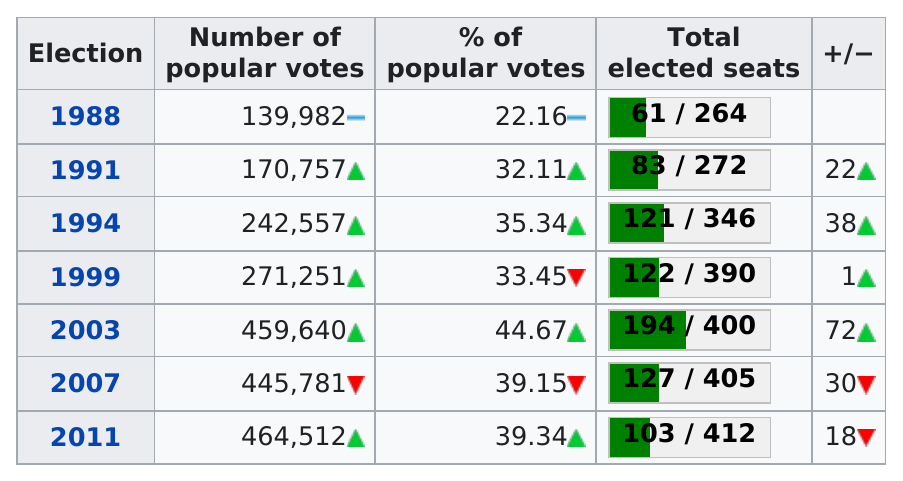Specify some key components in this picture. In 1991, there were a total of 83 elected seats. In the year 1994, a total of 121 seats were won. The 2003 election had the highest percentage of popular votes out of the two options provided. The last election to have under 35% of the popular votes was held in 1999. The 2003 election was the only one in which the popular vote exceeded 450,000. 